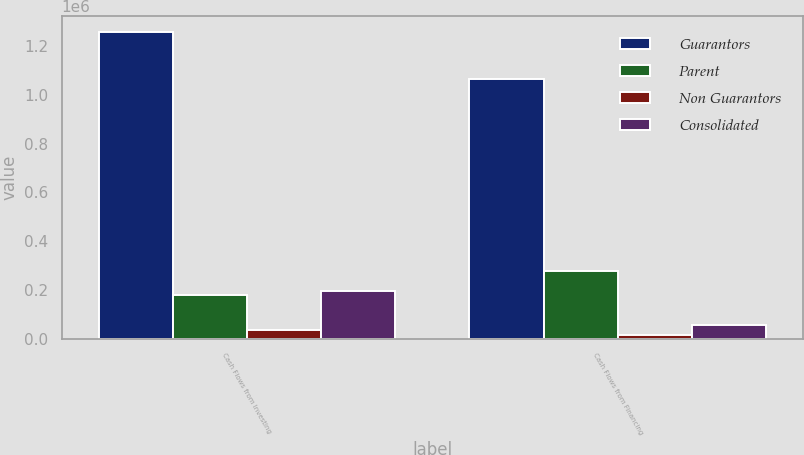Convert chart. <chart><loc_0><loc_0><loc_500><loc_500><stacked_bar_chart><ecel><fcel>Cash Flows from Investing<fcel>Cash Flows from Financing<nl><fcel>Guarantors<fcel>1.25893e+06<fcel>1.06572e+06<nl><fcel>Parent<fcel>180800<fcel>277430<nl><fcel>Non Guarantors<fcel>36162<fcel>15803<nl><fcel>Consolidated<fcel>198374<fcel>55234<nl></chart> 